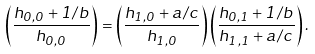Convert formula to latex. <formula><loc_0><loc_0><loc_500><loc_500>\left ( \frac { h _ { 0 , 0 } + 1 / b } { h _ { 0 , 0 } } \right ) = \left ( \frac { h _ { 1 , 0 } + a / c } { h _ { 1 , 0 } } \right ) \left ( \frac { h _ { 0 , 1 } + 1 / b } { h _ { 1 , 1 } + a / c } \right ) .</formula> 